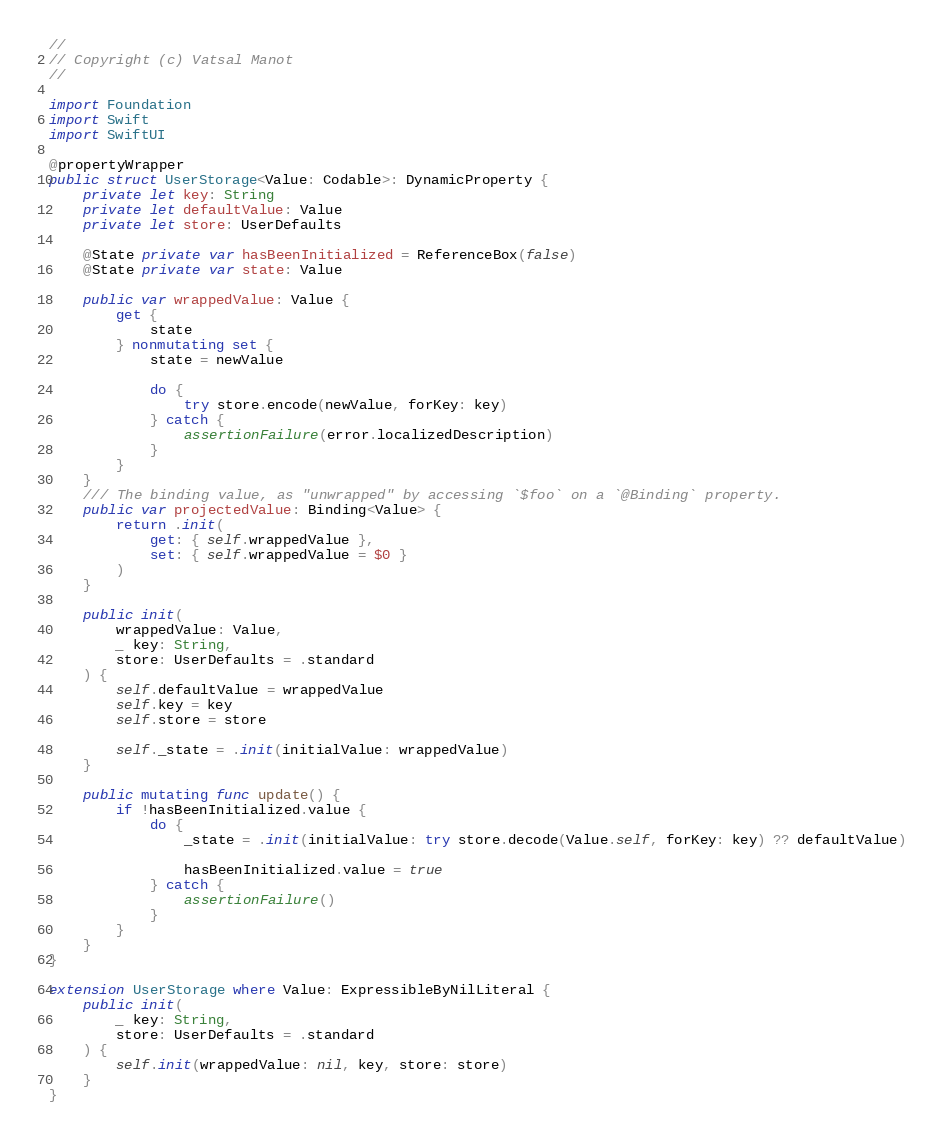Convert code to text. <code><loc_0><loc_0><loc_500><loc_500><_Swift_>//
// Copyright (c) Vatsal Manot
//

import Foundation
import Swift
import SwiftUI

@propertyWrapper
public struct UserStorage<Value: Codable>: DynamicProperty {
    private let key: String
    private let defaultValue: Value
    private let store: UserDefaults
    
    @State private var hasBeenInitialized = ReferenceBox(false)
    @State private var state: Value
    
    public var wrappedValue: Value {
        get {
            state
        } nonmutating set {
            state = newValue
            
            do {
                try store.encode(newValue, forKey: key)
            } catch {
                assertionFailure(error.localizedDescription)
            }
        }
    }
    /// The binding value, as "unwrapped" by accessing `$foo` on a `@Binding` property.
    public var projectedValue: Binding<Value> {
        return .init(
            get: { self.wrappedValue },
            set: { self.wrappedValue = $0 }
        )
    }
    
    public init(
        wrappedValue: Value,
        _ key: String,
        store: UserDefaults = .standard
    ) {
        self.defaultValue = wrappedValue
        self.key = key
        self.store = store
        
        self._state = .init(initialValue: wrappedValue)
    }
    
    public mutating func update() {
        if !hasBeenInitialized.value {
            do {
                _state = .init(initialValue: try store.decode(Value.self, forKey: key) ?? defaultValue)
                
                hasBeenInitialized.value = true
            } catch {
                assertionFailure()
            }
        }
    }
}

extension UserStorage where Value: ExpressibleByNilLiteral {
    public init(
        _ key: String,
        store: UserDefaults = .standard
    ) {
        self.init(wrappedValue: nil, key, store: store)
    }
}
</code> 